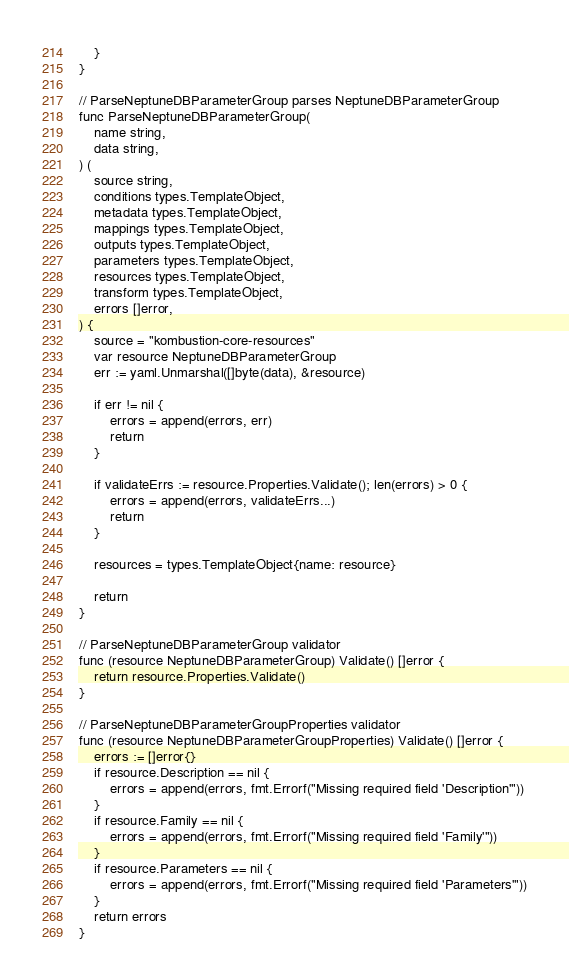<code> <loc_0><loc_0><loc_500><loc_500><_Go_>	}
}

// ParseNeptuneDBParameterGroup parses NeptuneDBParameterGroup
func ParseNeptuneDBParameterGroup(
	name string,
	data string,
) (
	source string,
	conditions types.TemplateObject,
	metadata types.TemplateObject,
	mappings types.TemplateObject,
	outputs types.TemplateObject,
	parameters types.TemplateObject,
	resources types.TemplateObject,
	transform types.TemplateObject,
	errors []error,
) {
	source = "kombustion-core-resources"
	var resource NeptuneDBParameterGroup
	err := yaml.Unmarshal([]byte(data), &resource)

	if err != nil {
		errors = append(errors, err)
		return
	}

	if validateErrs := resource.Properties.Validate(); len(errors) > 0 {
		errors = append(errors, validateErrs...)
		return
	}

	resources = types.TemplateObject{name: resource}

	return
}

// ParseNeptuneDBParameterGroup validator
func (resource NeptuneDBParameterGroup) Validate() []error {
	return resource.Properties.Validate()
}

// ParseNeptuneDBParameterGroupProperties validator
func (resource NeptuneDBParameterGroupProperties) Validate() []error {
	errors := []error{}
	if resource.Description == nil {
		errors = append(errors, fmt.Errorf("Missing required field 'Description'"))
	}
	if resource.Family == nil {
		errors = append(errors, fmt.Errorf("Missing required field 'Family'"))
	}
	if resource.Parameters == nil {
		errors = append(errors, fmt.Errorf("Missing required field 'Parameters'"))
	}
	return errors
}
</code> 